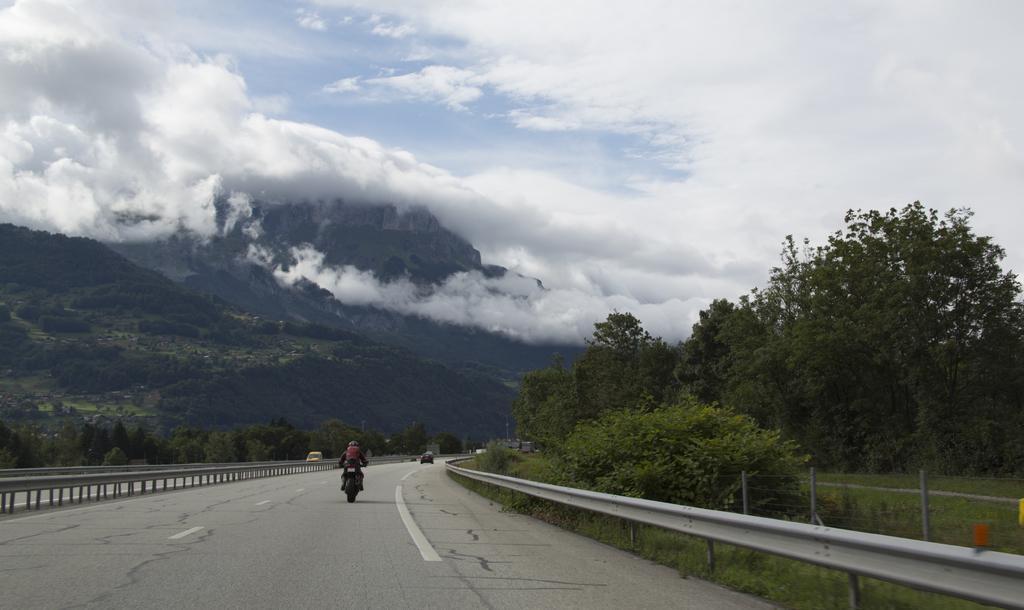In one or two sentences, can you explain what this image depicts? In this image we can see vehicles moving on the road, we can see the fence, trees, hills and the sky with clouds in the background. 